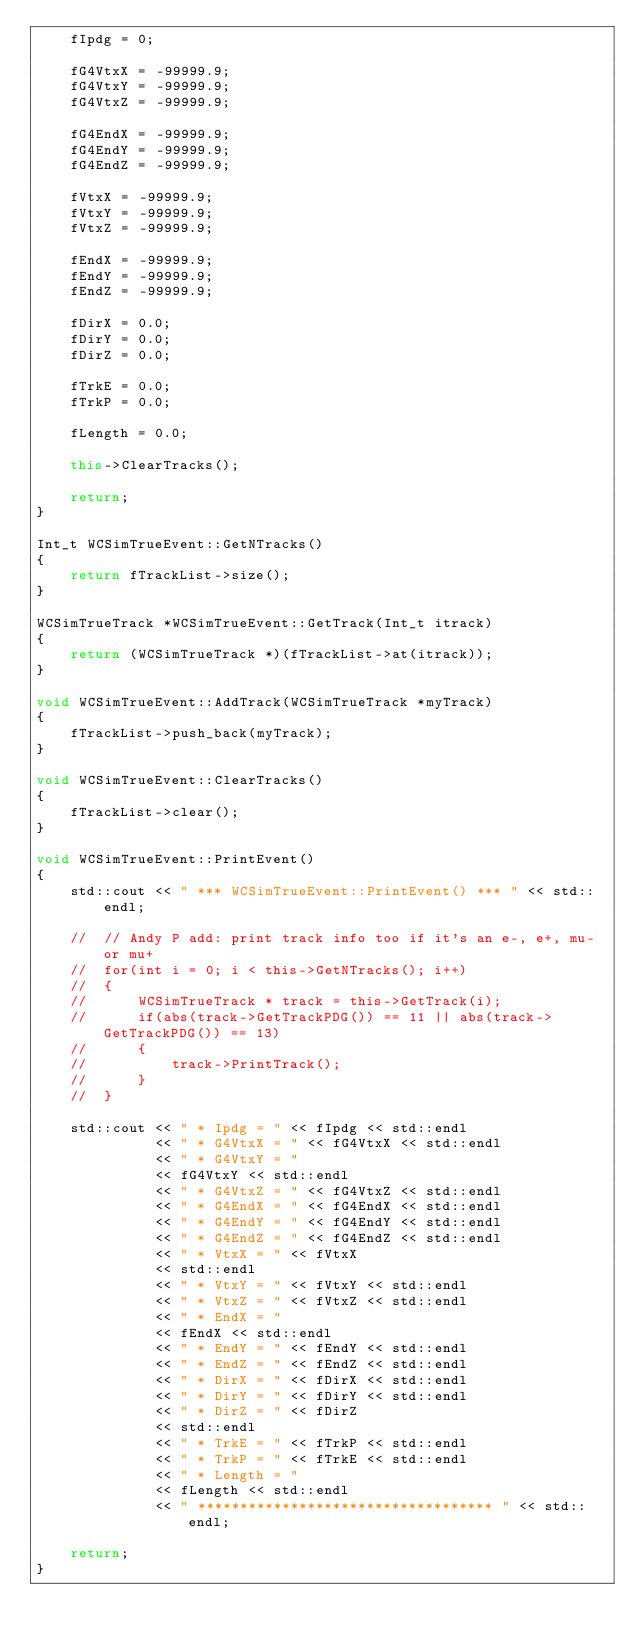Convert code to text. <code><loc_0><loc_0><loc_500><loc_500><_C++_>	fIpdg = 0;

	fG4VtxX = -99999.9;
	fG4VtxY = -99999.9;
	fG4VtxZ = -99999.9;

	fG4EndX = -99999.9;
	fG4EndY = -99999.9;
	fG4EndZ = -99999.9;

	fVtxX = -99999.9;
	fVtxY = -99999.9;
	fVtxZ = -99999.9;

	fEndX = -99999.9;
	fEndY = -99999.9;
	fEndZ = -99999.9;

	fDirX = 0.0;
	fDirY = 0.0;
	fDirZ = 0.0;

	fTrkE = 0.0;
	fTrkP = 0.0;

	fLength = 0.0;

	this->ClearTracks();

	return;
}

Int_t WCSimTrueEvent::GetNTracks()
{
	return fTrackList->size();
}

WCSimTrueTrack *WCSimTrueEvent::GetTrack(Int_t itrack)
{
	return (WCSimTrueTrack *)(fTrackList->at(itrack));
}

void WCSimTrueEvent::AddTrack(WCSimTrueTrack *myTrack)
{
	fTrackList->push_back(myTrack);
}

void WCSimTrueEvent::ClearTracks()
{
	fTrackList->clear();
}

void WCSimTrueEvent::PrintEvent()
{
	std::cout << " *** WCSimTrueEvent::PrintEvent() *** " << std::endl;

	//	// Andy P add: print track info too if it's an e-, e+, mu- or mu+
	//	for(int i = 0; i < this->GetNTracks(); i++)
	//	{
	//		WCSimTrueTrack * track = this->GetTrack(i);
	//		if(abs(track->GetTrackPDG()) == 11 || abs(track->GetTrackPDG()) == 13)
	//		{
	//			track->PrintTrack();
	//		}
	//	}

	std::cout << " * Ipdg = " << fIpdg << std::endl
			  << " * G4VtxX = " << fG4VtxX << std::endl
			  << " * G4VtxY = "
			  << fG4VtxY << std::endl
			  << " * G4VtxZ = " << fG4VtxZ << std::endl
			  << " * G4EndX = " << fG4EndX << std::endl
			  << " * G4EndY = " << fG4EndY << std::endl
			  << " * G4EndZ = " << fG4EndZ << std::endl
			  << " * VtxX = " << fVtxX
			  << std::endl
			  << " * VtxY = " << fVtxY << std::endl
			  << " * VtxZ = " << fVtxZ << std::endl
			  << " * EndX = "
			  << fEndX << std::endl
			  << " * EndY = " << fEndY << std::endl
			  << " * EndZ = " << fEndZ << std::endl
			  << " * DirX = " << fDirX << std::endl
			  << " * DirY = " << fDirY << std::endl
			  << " * DirZ = " << fDirZ
			  << std::endl
			  << " * TrkE = " << fTrkP << std::endl
			  << " * TrkP = " << fTrkE << std::endl
			  << " * Length = "
			  << fLength << std::endl
			  << " *********************************** " << std::endl;

	return;
}
</code> 